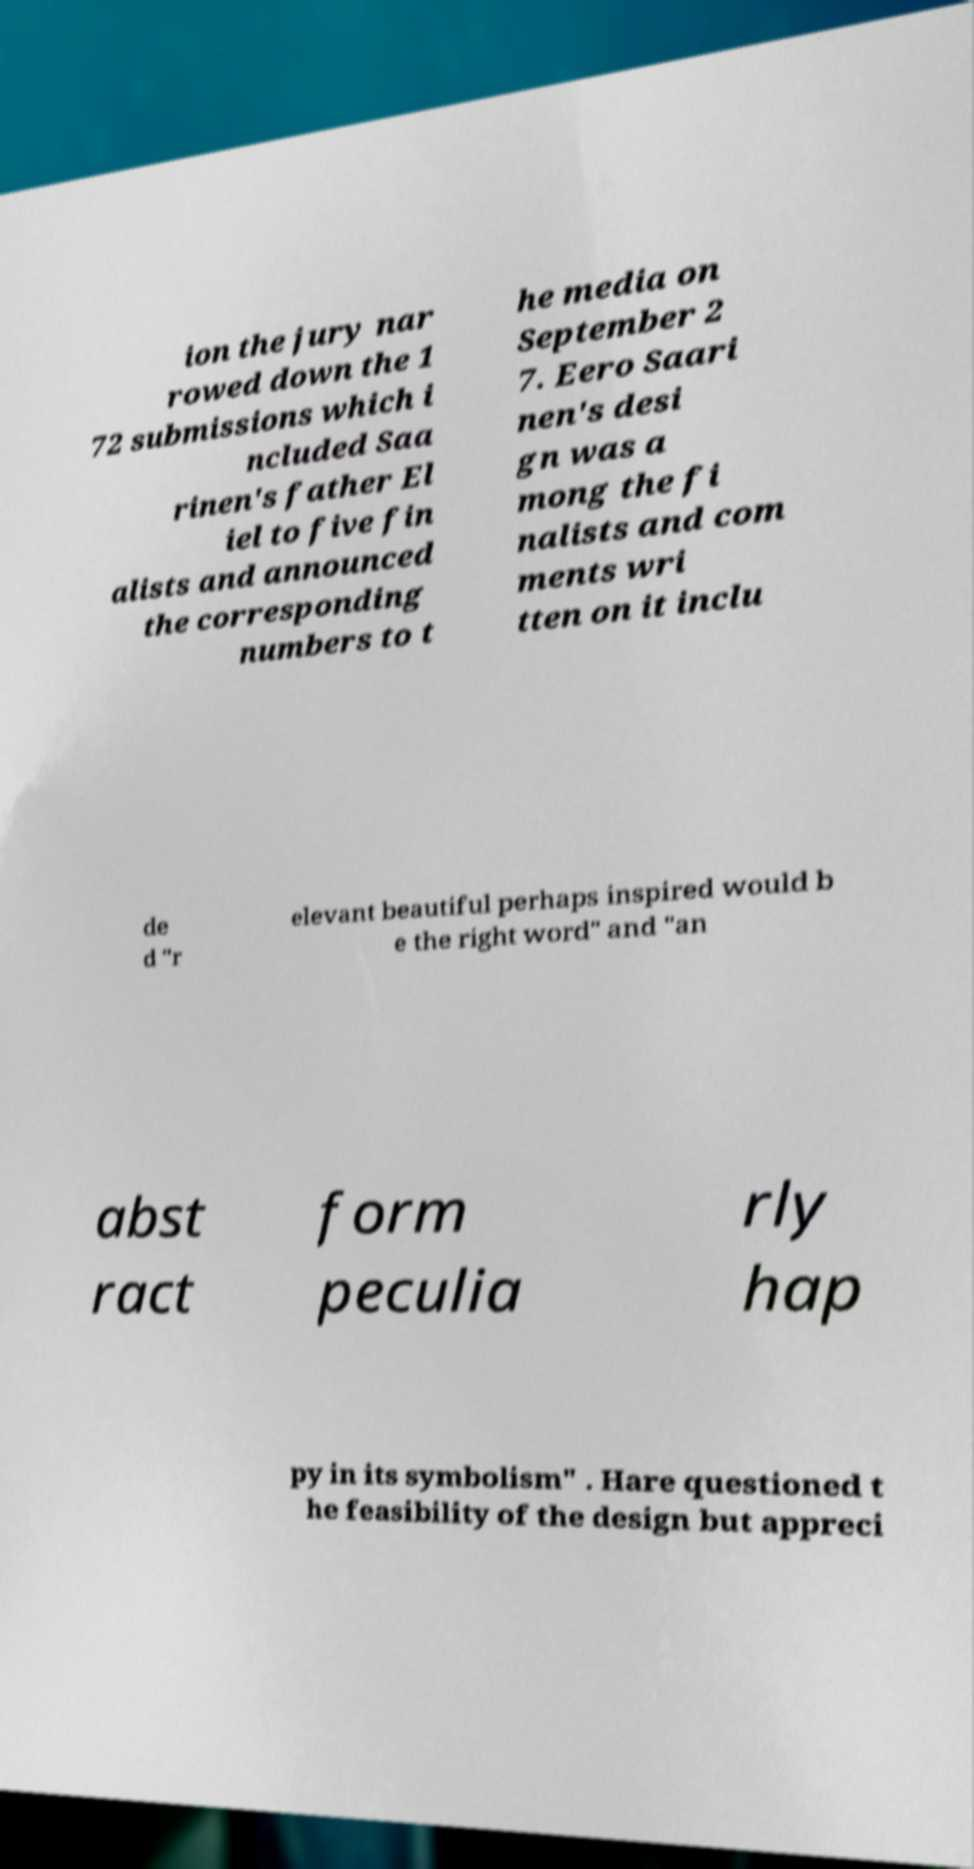I need the written content from this picture converted into text. Can you do that? ion the jury nar rowed down the 1 72 submissions which i ncluded Saa rinen's father El iel to five fin alists and announced the corresponding numbers to t he media on September 2 7. Eero Saari nen's desi gn was a mong the fi nalists and com ments wri tten on it inclu de d "r elevant beautiful perhaps inspired would b e the right word" and "an abst ract form peculia rly hap py in its symbolism" . Hare questioned t he feasibility of the design but appreci 